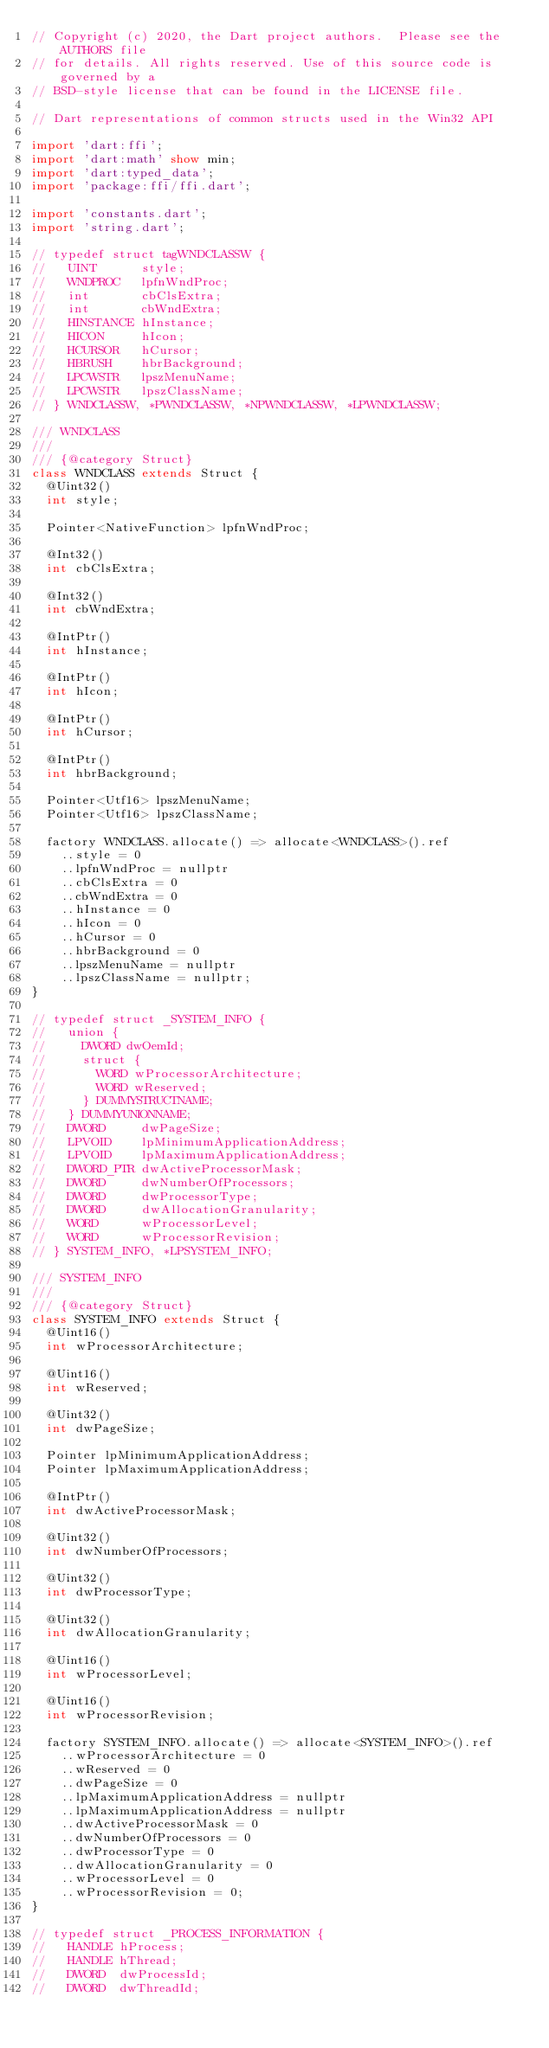Convert code to text. <code><loc_0><loc_0><loc_500><loc_500><_Dart_>// Copyright (c) 2020, the Dart project authors.  Please see the AUTHORS file
// for details. All rights reserved. Use of this source code is governed by a
// BSD-style license that can be found in the LICENSE file.

// Dart representations of common structs used in the Win32 API

import 'dart:ffi';
import 'dart:math' show min;
import 'dart:typed_data';
import 'package:ffi/ffi.dart';

import 'constants.dart';
import 'string.dart';

// typedef struct tagWNDCLASSW {
//   UINT      style;
//   WNDPROC   lpfnWndProc;
//   int       cbClsExtra;
//   int       cbWndExtra;
//   HINSTANCE hInstance;
//   HICON     hIcon;
//   HCURSOR   hCursor;
//   HBRUSH    hbrBackground;
//   LPCWSTR   lpszMenuName;
//   LPCWSTR   lpszClassName;
// } WNDCLASSW, *PWNDCLASSW, *NPWNDCLASSW, *LPWNDCLASSW;

/// WNDCLASS
///
/// {@category Struct}
class WNDCLASS extends Struct {
  @Uint32()
  int style;

  Pointer<NativeFunction> lpfnWndProc;

  @Int32()
  int cbClsExtra;

  @Int32()
  int cbWndExtra;

  @IntPtr()
  int hInstance;

  @IntPtr()
  int hIcon;

  @IntPtr()
  int hCursor;

  @IntPtr()
  int hbrBackground;

  Pointer<Utf16> lpszMenuName;
  Pointer<Utf16> lpszClassName;

  factory WNDCLASS.allocate() => allocate<WNDCLASS>().ref
    ..style = 0
    ..lpfnWndProc = nullptr
    ..cbClsExtra = 0
    ..cbWndExtra = 0
    ..hInstance = 0
    ..hIcon = 0
    ..hCursor = 0
    ..hbrBackground = 0
    ..lpszMenuName = nullptr
    ..lpszClassName = nullptr;
}

// typedef struct _SYSTEM_INFO {
//   union {
//     DWORD dwOemId;
//     struct {
//       WORD wProcessorArchitecture;
//       WORD wReserved;
//     } DUMMYSTRUCTNAME;
//   } DUMMYUNIONNAME;
//   DWORD     dwPageSize;
//   LPVOID    lpMinimumApplicationAddress;
//   LPVOID    lpMaximumApplicationAddress;
//   DWORD_PTR dwActiveProcessorMask;
//   DWORD     dwNumberOfProcessors;
//   DWORD     dwProcessorType;
//   DWORD     dwAllocationGranularity;
//   WORD      wProcessorLevel;
//   WORD      wProcessorRevision;
// } SYSTEM_INFO, *LPSYSTEM_INFO;

/// SYSTEM_INFO
///
/// {@category Struct}
class SYSTEM_INFO extends Struct {
  @Uint16()
  int wProcessorArchitecture;

  @Uint16()
  int wReserved;

  @Uint32()
  int dwPageSize;

  Pointer lpMinimumApplicationAddress;
  Pointer lpMaximumApplicationAddress;

  @IntPtr()
  int dwActiveProcessorMask;

  @Uint32()
  int dwNumberOfProcessors;

  @Uint32()
  int dwProcessorType;

  @Uint32()
  int dwAllocationGranularity;

  @Uint16()
  int wProcessorLevel;

  @Uint16()
  int wProcessorRevision;

  factory SYSTEM_INFO.allocate() => allocate<SYSTEM_INFO>().ref
    ..wProcessorArchitecture = 0
    ..wReserved = 0
    ..dwPageSize = 0
    ..lpMaximumApplicationAddress = nullptr
    ..lpMaximumApplicationAddress = nullptr
    ..dwActiveProcessorMask = 0
    ..dwNumberOfProcessors = 0
    ..dwProcessorType = 0
    ..dwAllocationGranularity = 0
    ..wProcessorLevel = 0
    ..wProcessorRevision = 0;
}

// typedef struct _PROCESS_INFORMATION {
//   HANDLE hProcess;
//   HANDLE hThread;
//   DWORD  dwProcessId;
//   DWORD  dwThreadId;</code> 